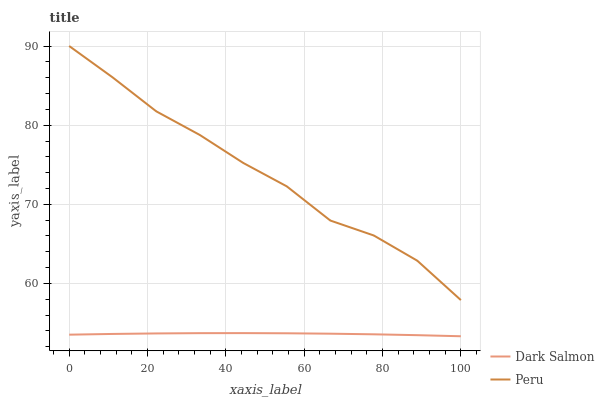Does Peru have the minimum area under the curve?
Answer yes or no. No. Is Peru the smoothest?
Answer yes or no. No. Does Peru have the lowest value?
Answer yes or no. No. Is Dark Salmon less than Peru?
Answer yes or no. Yes. Is Peru greater than Dark Salmon?
Answer yes or no. Yes. Does Dark Salmon intersect Peru?
Answer yes or no. No. 